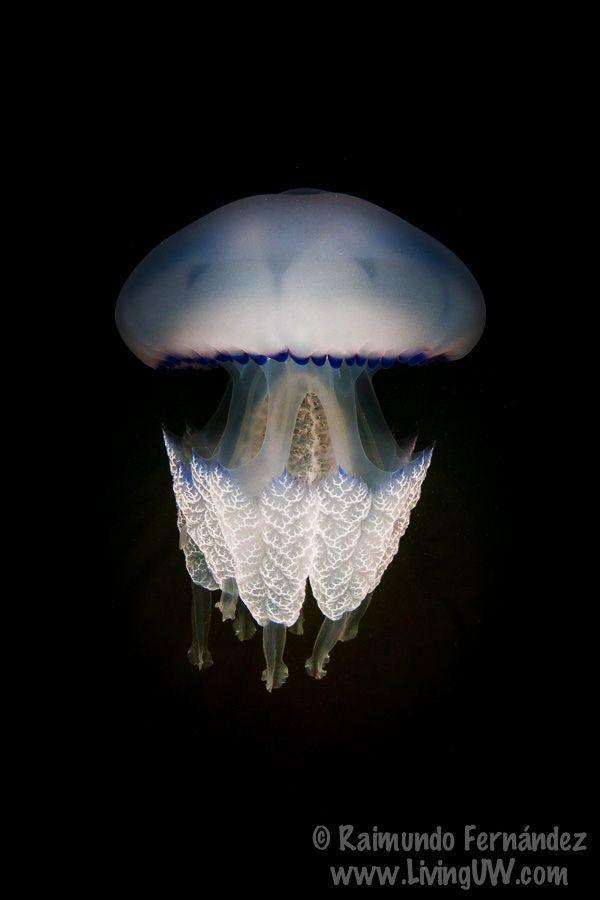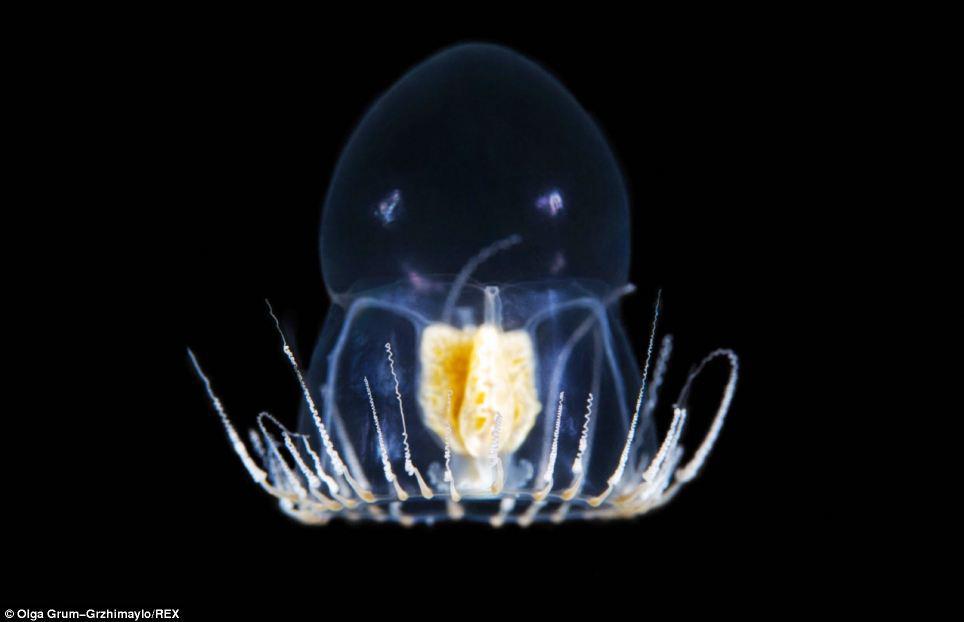The first image is the image on the left, the second image is the image on the right. Evaluate the accuracy of this statement regarding the images: "Each of the images shows a single jellyfish that has been photographed in a dark part of ocean where there is little or no light.". Is it true? Answer yes or no. Yes. 